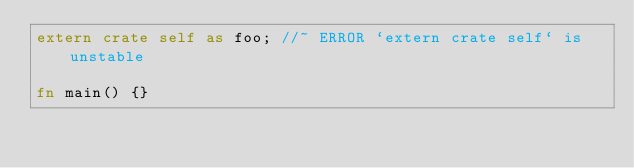<code> <loc_0><loc_0><loc_500><loc_500><_Rust_>extern crate self as foo; //~ ERROR `extern crate self` is unstable

fn main() {}
</code> 